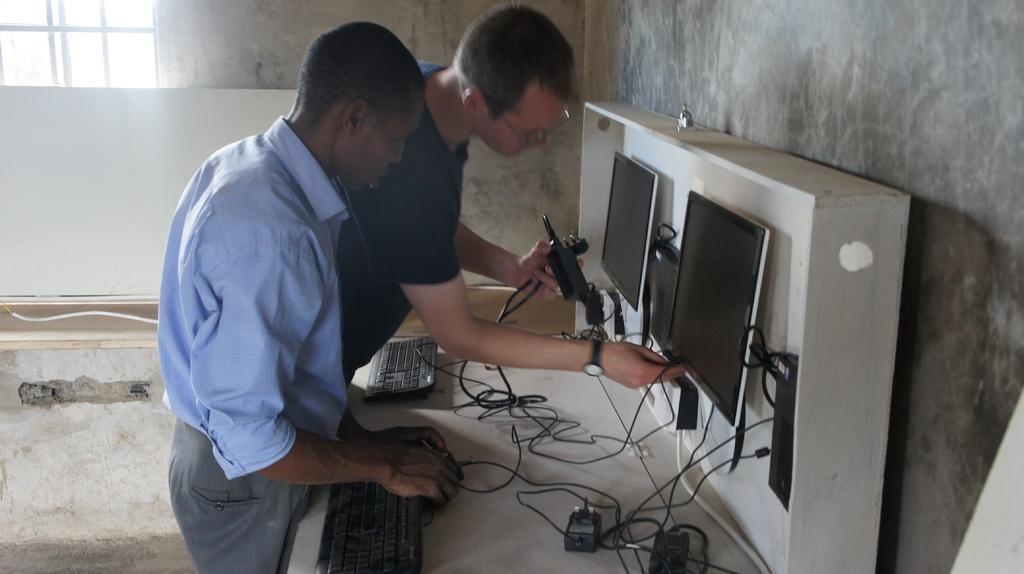How would you summarize this image in a sentence or two? In the picture I can see two men standing on the floor. I can see a man wearing a shirt and he is holding the adapter in his hands. I can see another man wearing a T-shirt and he is fixing the cables. I can see the computer monitors on the wooden walls. I can see the keyboards and cables on the wooden table. I can see the glass window on the top left side of the picture. 